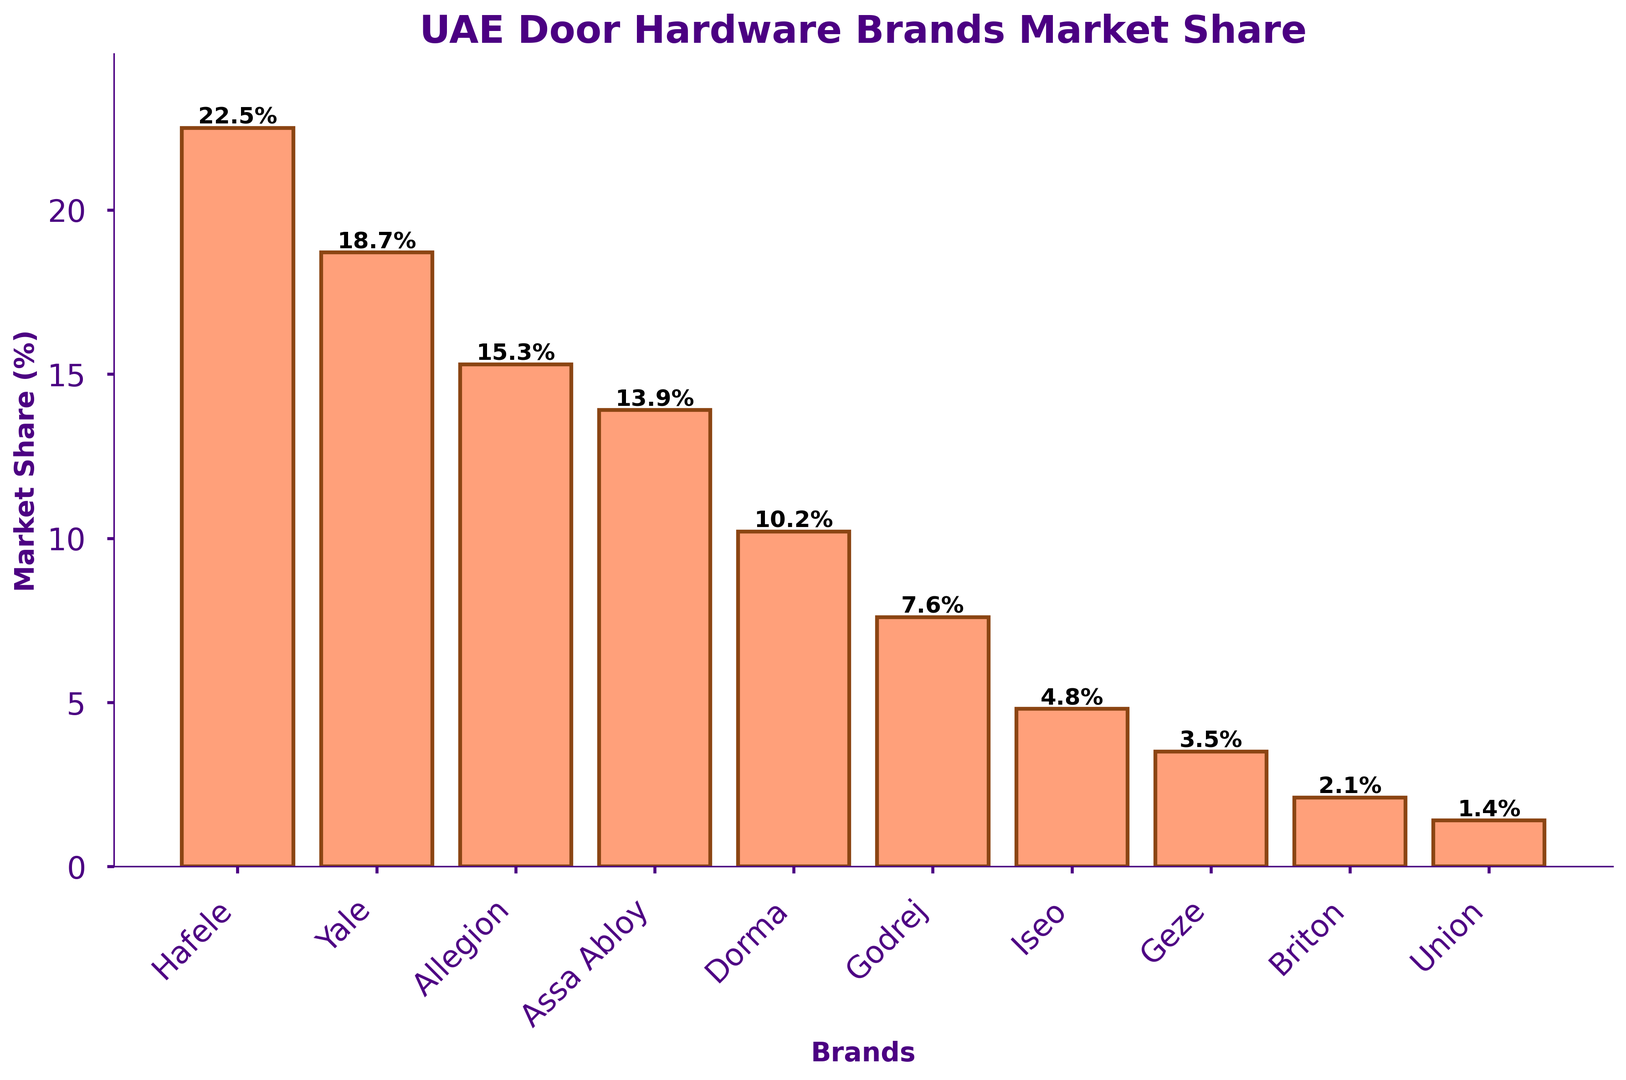Which brand has the highest market share? By looking at the top of the bars, Hafele has the highest bar, which indicates it has the highest market share.
Answer: Hafele Which two brands have the closest market share values? Comparing the lengths of all the bars, Allegion and Assa Abloy have bars that are closest in height.
Answer: Allegion and Assa Abloy What is the combined market share of the top three brands? Add the market shares of Hafele (22.5), Yale (18.7), and Allegion (15.3) to get the total. 22.5 + 18.7 + 15.3 = 56.5
Answer: 56.5% By how much does Hafele's market share exceed Yale's? Subtract the market share of Yale from Hafele: 22.5 - 18.7 = 3.8
Answer: 3.8% Rank the brands in decreasing order of market share. By comparing the heights of all the bars, the order is Hafele, Yale, Allegion, Assa Abloy, Dorma, Godrej, Iseo, Geze, Briton, Union.
Answer: Hafele, Yale, Allegion, Assa Abloy, Dorma, Godrej, Iseo, Geze, Briton, Union What is the total market share of all brands with less than 10% market share individually? Sum the market shares of Assa Abloy (13.9), Dorma (10.2), Godrej (7.6), Iseo (4.8), Geze (3.5), Briton (2.1), and Union (1.4). 10.2 + 7.6 + 4.8 + 3.5 + 2.1 + 1.4 = 19.4
Answer: 19.4% Which brand has the smallest market share and what is its value? By looking at the shortest bar, Union has the smallest market share. The value is at the top of the bar, 1.4%.
Answer: Union, 1.4% Which brands have market shares greater than 15%? Checking the brands with bars that visually appear to be above 15, these are Hafele, Yale, and Allegion.
Answer: Hafele, Yale, Allegion What is the difference in market share between Dorma and Godrej? Subtract the market share of Godrej from Dorma: 10.2 - 7.6 = 2.6
Answer: 2.6% 